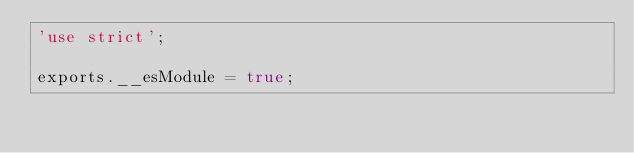Convert code to text. <code><loc_0><loc_0><loc_500><loc_500><_JavaScript_>'use strict';

exports.__esModule = true;
</code> 